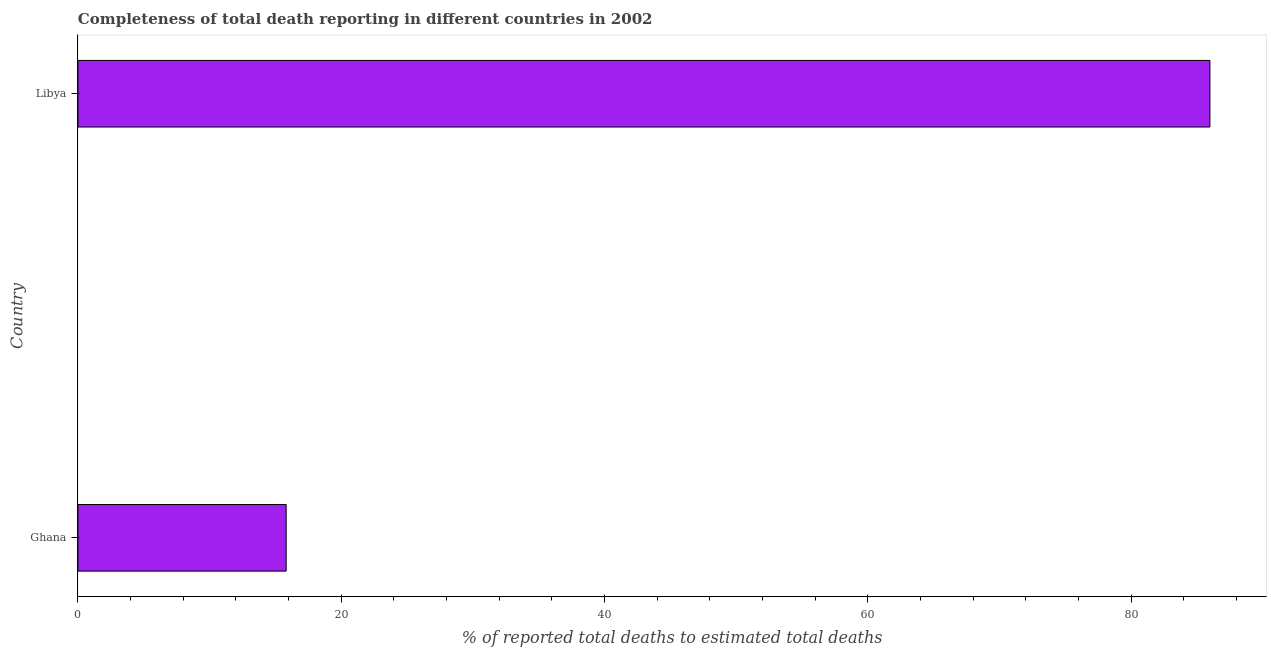Does the graph contain any zero values?
Your answer should be compact. No. What is the title of the graph?
Give a very brief answer. Completeness of total death reporting in different countries in 2002. What is the label or title of the X-axis?
Make the answer very short. % of reported total deaths to estimated total deaths. What is the label or title of the Y-axis?
Offer a terse response. Country. What is the completeness of total death reports in Ghana?
Make the answer very short. 15.82. Across all countries, what is the maximum completeness of total death reports?
Ensure brevity in your answer.  85.99. Across all countries, what is the minimum completeness of total death reports?
Your response must be concise. 15.82. In which country was the completeness of total death reports maximum?
Keep it short and to the point. Libya. In which country was the completeness of total death reports minimum?
Provide a succinct answer. Ghana. What is the sum of the completeness of total death reports?
Ensure brevity in your answer.  101.81. What is the difference between the completeness of total death reports in Ghana and Libya?
Offer a very short reply. -70.17. What is the average completeness of total death reports per country?
Provide a succinct answer. 50.9. What is the median completeness of total death reports?
Offer a terse response. 50.9. In how many countries, is the completeness of total death reports greater than 68 %?
Your answer should be very brief. 1. What is the ratio of the completeness of total death reports in Ghana to that in Libya?
Your answer should be very brief. 0.18. Are all the bars in the graph horizontal?
Provide a succinct answer. Yes. How many countries are there in the graph?
Your response must be concise. 2. What is the difference between two consecutive major ticks on the X-axis?
Provide a short and direct response. 20. What is the % of reported total deaths to estimated total deaths of Ghana?
Ensure brevity in your answer.  15.82. What is the % of reported total deaths to estimated total deaths of Libya?
Provide a succinct answer. 85.99. What is the difference between the % of reported total deaths to estimated total deaths in Ghana and Libya?
Offer a terse response. -70.18. What is the ratio of the % of reported total deaths to estimated total deaths in Ghana to that in Libya?
Your answer should be compact. 0.18. 